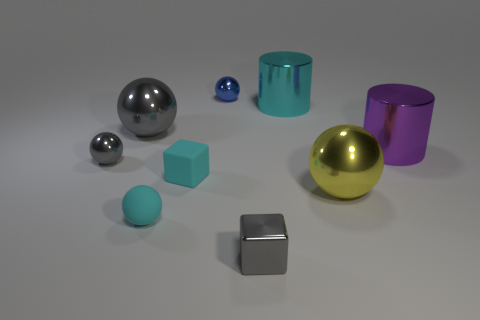Subtract all big yellow metal spheres. How many spheres are left? 4 Add 1 cubes. How many objects exist? 10 Subtract all gray balls. How many balls are left? 3 Subtract all cubes. How many objects are left? 7 Subtract 2 balls. How many balls are left? 3 Subtract all red cylinders. Subtract all purple balls. How many cylinders are left? 2 Subtract all purple cylinders. How many blue balls are left? 1 Subtract all small shiny cylinders. Subtract all small blue things. How many objects are left? 8 Add 4 small cyan spheres. How many small cyan spheres are left? 5 Add 4 purple things. How many purple things exist? 5 